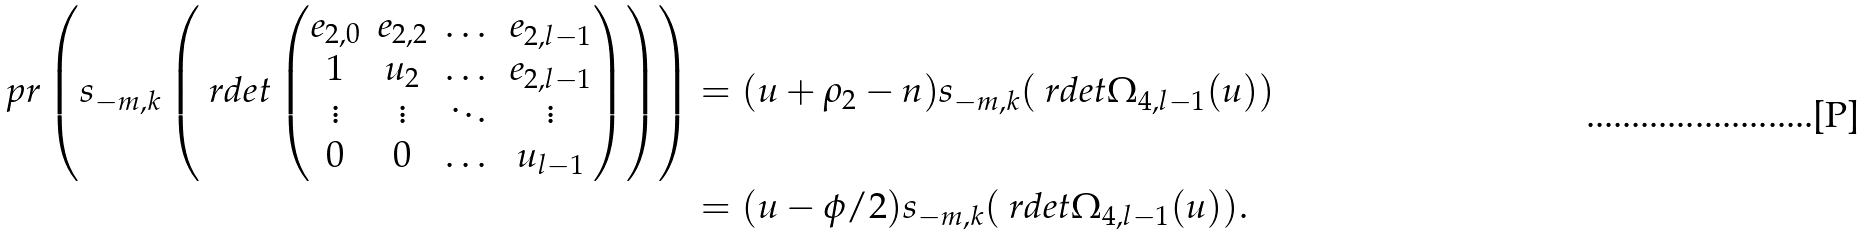<formula> <loc_0><loc_0><loc_500><loc_500>\ p r \left ( s _ { - m , k } \left ( \ r d e t \begin{pmatrix} e _ { 2 , 0 } & e _ { 2 , 2 } & \dots & e _ { 2 , l - 1 } \\ 1 & u _ { 2 } & \dots & e _ { 2 , l - 1 } \\ \vdots & \vdots & \ddots & \vdots \\ 0 & 0 & \dots & u _ { l - 1 } \end{pmatrix} \right ) \right ) & = ( u + \rho _ { 2 } - n ) s _ { - m , k } ( \ r d e t \Omega _ { 4 , l - 1 } ( u ) ) \\ & = ( u - \phi / 2 ) s _ { - m , k } ( \ r d e t \Omega _ { 4 , l - 1 } ( u ) ) .</formula> 